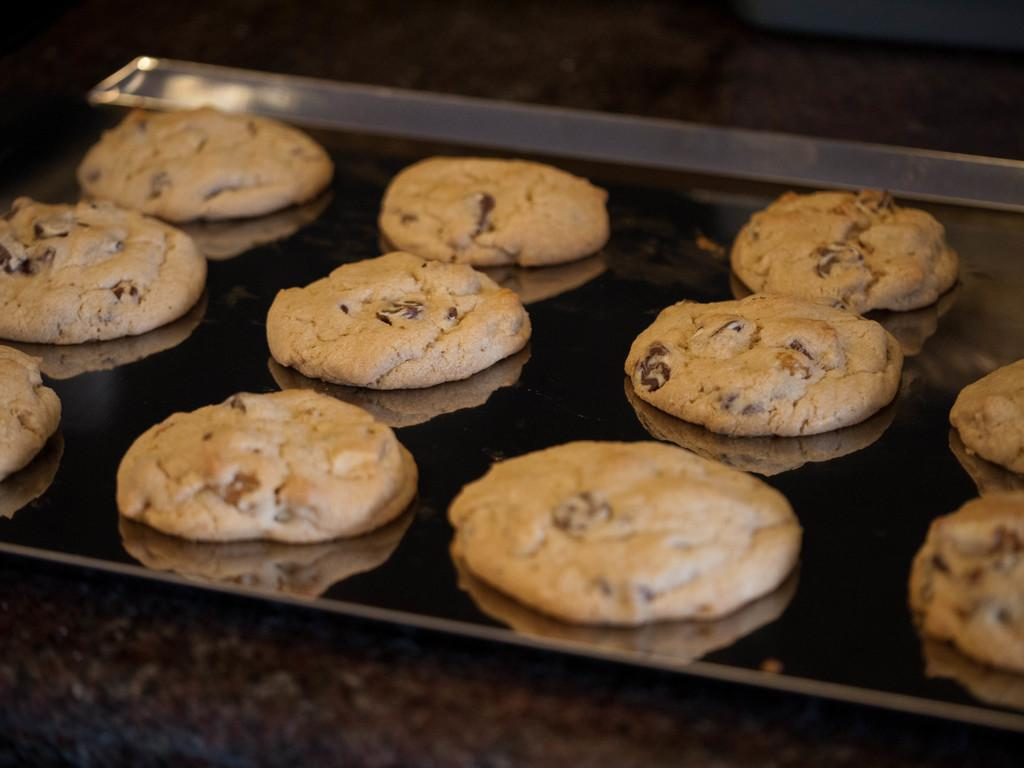What is located in the center of the image? There is a tray in the center of the image. What is on the tray? There are cookies on the tray. Where is the tray placed? The tray is on a table. How many bushes are visible in the image? There are no bushes visible in the image; it only shows a tray with cookies on a table. 